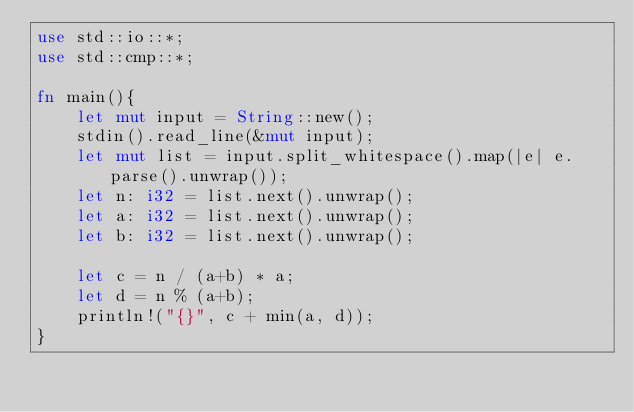<code> <loc_0><loc_0><loc_500><loc_500><_Rust_>use std::io::*;
use std::cmp::*;

fn main(){
    let mut input = String::new();
    stdin().read_line(&mut input);
    let mut list = input.split_whitespace().map(|e| e.parse().unwrap());
    let n: i32 = list.next().unwrap();
    let a: i32 = list.next().unwrap();
    let b: i32 = list.next().unwrap();

    let c = n / (a+b) * a;
    let d = n % (a+b);
    println!("{}", c + min(a, d));
}
</code> 